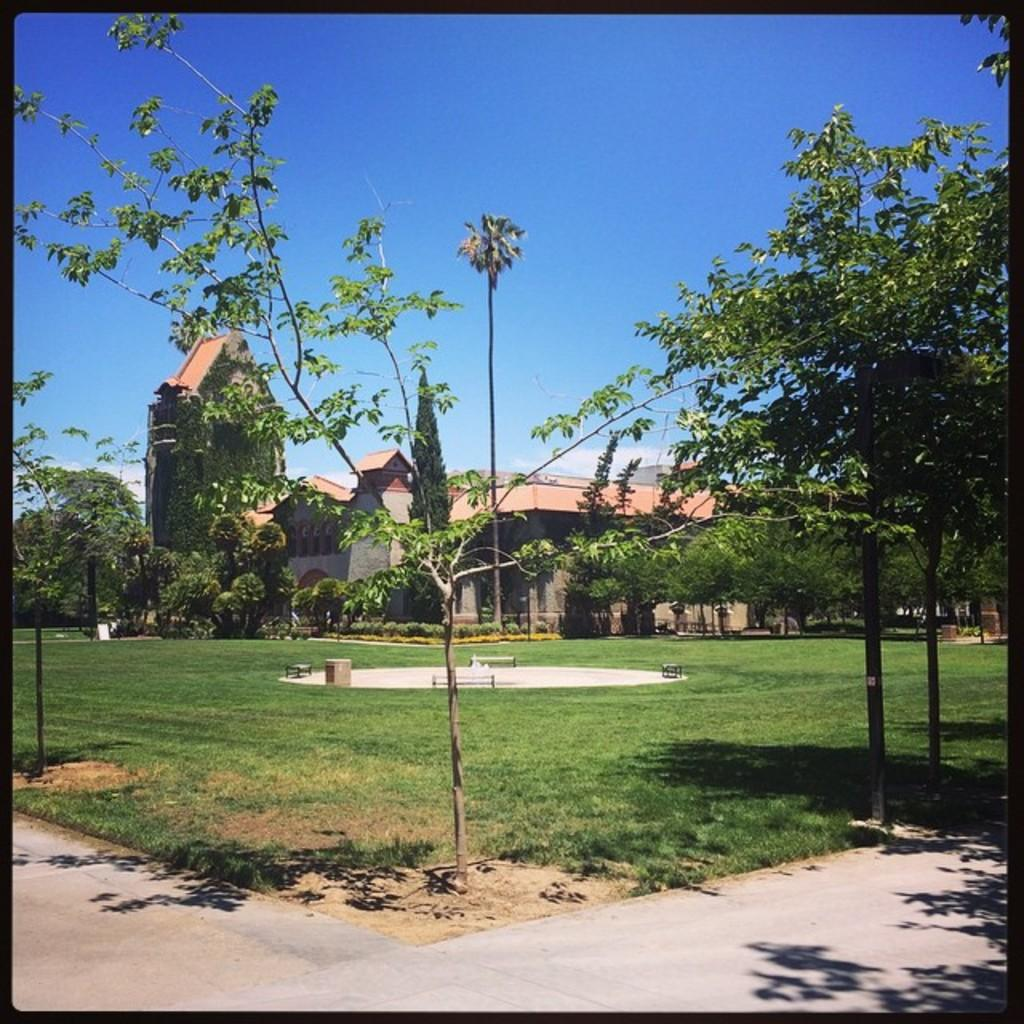What is the main feature of the image? There is a fountain area in the image. What is the fountain area covered with? The fountain area is covered with grass. What other natural elements can be seen in the image? There are trees in the image. What type of path is present in the image? There is a walking path in the image. What can be seen in the background of the image? There is a house in the background of the image. What is the color of the sky in the image? The sky is blue in the image. What type of oil can be seen dripping from the trees in the image? There is no oil present in the image; the trees are not depicted as dripping any substance. What type of writing can be seen on the fountain in the image? There is no writing present on the fountain in the image. What type of bears can be seen playing near the walking path in the image? There are no bears present in the image; the image only features a fountain area, trees, a walking path, and a house in the background. 